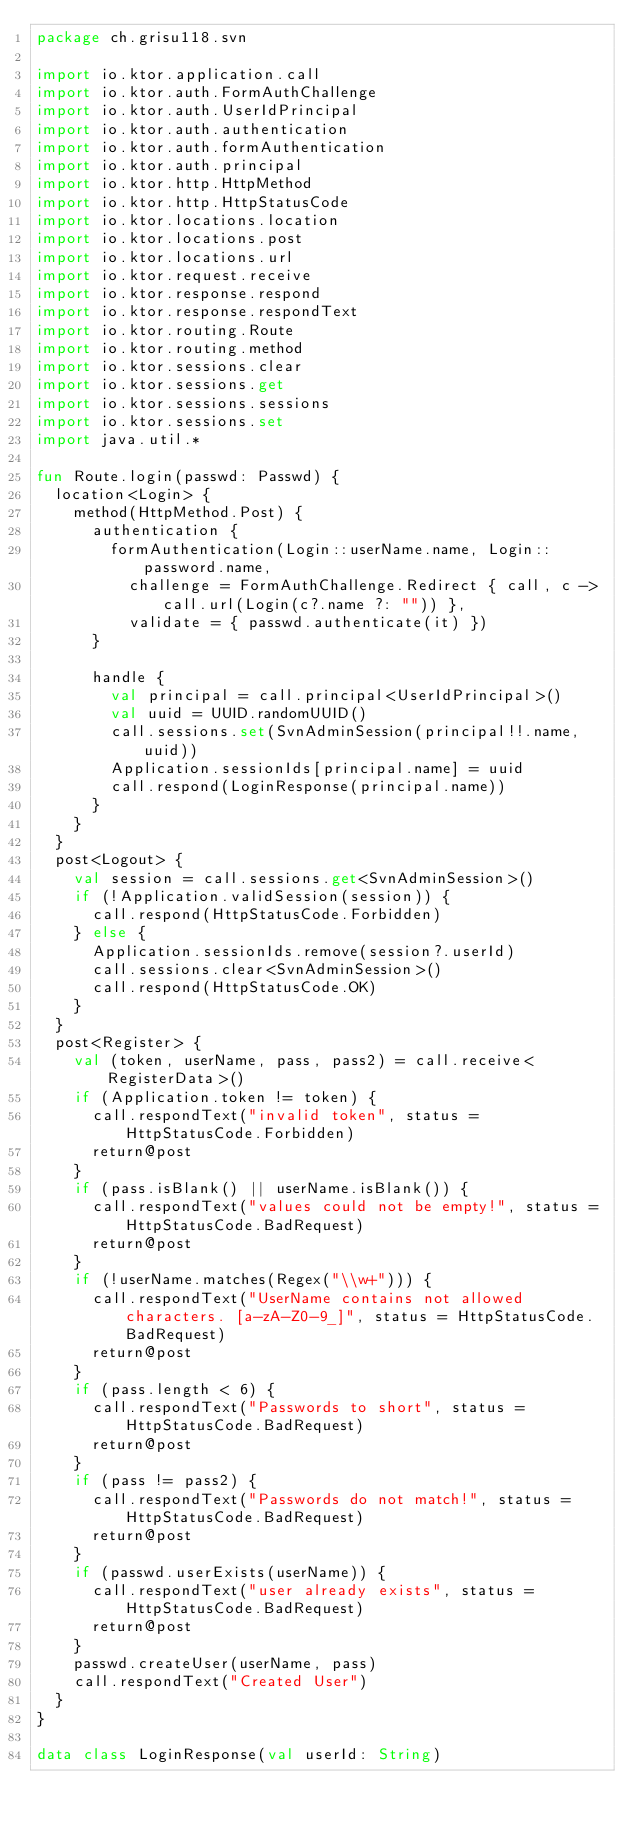Convert code to text. <code><loc_0><loc_0><loc_500><loc_500><_Kotlin_>package ch.grisu118.svn

import io.ktor.application.call
import io.ktor.auth.FormAuthChallenge
import io.ktor.auth.UserIdPrincipal
import io.ktor.auth.authentication
import io.ktor.auth.formAuthentication
import io.ktor.auth.principal
import io.ktor.http.HttpMethod
import io.ktor.http.HttpStatusCode
import io.ktor.locations.location
import io.ktor.locations.post
import io.ktor.locations.url
import io.ktor.request.receive
import io.ktor.response.respond
import io.ktor.response.respondText
import io.ktor.routing.Route
import io.ktor.routing.method
import io.ktor.sessions.clear
import io.ktor.sessions.get
import io.ktor.sessions.sessions
import io.ktor.sessions.set
import java.util.*

fun Route.login(passwd: Passwd) {
  location<Login> {
    method(HttpMethod.Post) {
      authentication {
        formAuthentication(Login::userName.name, Login::password.name,
          challenge = FormAuthChallenge.Redirect { call, c -> call.url(Login(c?.name ?: "")) },
          validate = { passwd.authenticate(it) })
      }

      handle {
        val principal = call.principal<UserIdPrincipal>()
        val uuid = UUID.randomUUID()
        call.sessions.set(SvnAdminSession(principal!!.name, uuid))
        Application.sessionIds[principal.name] = uuid
        call.respond(LoginResponse(principal.name))
      }
    }
  }
  post<Logout> {
    val session = call.sessions.get<SvnAdminSession>()
    if (!Application.validSession(session)) {
      call.respond(HttpStatusCode.Forbidden)
    } else {
      Application.sessionIds.remove(session?.userId)
      call.sessions.clear<SvnAdminSession>()
      call.respond(HttpStatusCode.OK)
    }
  }
  post<Register> {
    val (token, userName, pass, pass2) = call.receive<RegisterData>()
    if (Application.token != token) {
      call.respondText("invalid token", status = HttpStatusCode.Forbidden)
      return@post
    }
    if (pass.isBlank() || userName.isBlank()) {
      call.respondText("values could not be empty!", status = HttpStatusCode.BadRequest)
      return@post
    }
    if (!userName.matches(Regex("\\w+"))) {
      call.respondText("UserName contains not allowed characters. [a-zA-Z0-9_]", status = HttpStatusCode.BadRequest)
      return@post
    }
    if (pass.length < 6) {
      call.respondText("Passwords to short", status = HttpStatusCode.BadRequest)
      return@post
    }
    if (pass != pass2) {
      call.respondText("Passwords do not match!", status = HttpStatusCode.BadRequest)
      return@post
    }
    if (passwd.userExists(userName)) {
      call.respondText("user already exists", status = HttpStatusCode.BadRequest)
      return@post
    }
    passwd.createUser(userName, pass)
    call.respondText("Created User")
  }
}

data class LoginResponse(val userId: String)

</code> 